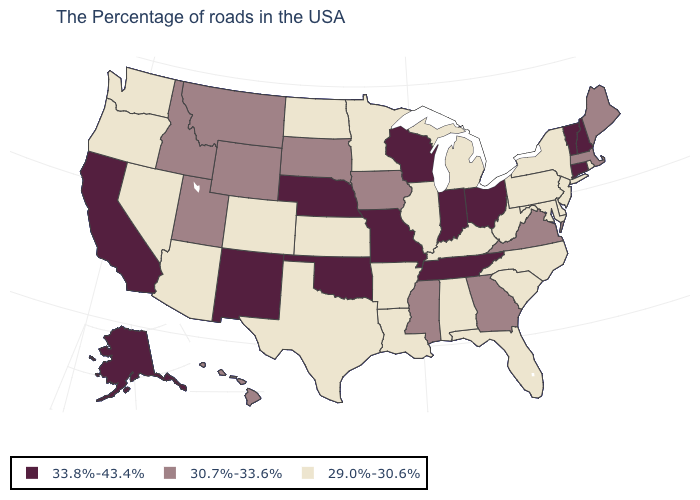Name the states that have a value in the range 29.0%-30.6%?
Keep it brief. Rhode Island, New York, New Jersey, Delaware, Maryland, Pennsylvania, North Carolina, South Carolina, West Virginia, Florida, Michigan, Kentucky, Alabama, Illinois, Louisiana, Arkansas, Minnesota, Kansas, Texas, North Dakota, Colorado, Arizona, Nevada, Washington, Oregon. What is the value of Massachusetts?
Short answer required. 30.7%-33.6%. How many symbols are there in the legend?
Short answer required. 3. What is the value of Georgia?
Give a very brief answer. 30.7%-33.6%. Among the states that border North Dakota , which have the highest value?
Concise answer only. South Dakota, Montana. What is the value of South Carolina?
Concise answer only. 29.0%-30.6%. Name the states that have a value in the range 30.7%-33.6%?
Quick response, please. Maine, Massachusetts, Virginia, Georgia, Mississippi, Iowa, South Dakota, Wyoming, Utah, Montana, Idaho, Hawaii. What is the highest value in the MidWest ?
Keep it brief. 33.8%-43.4%. What is the lowest value in the South?
Concise answer only. 29.0%-30.6%. Name the states that have a value in the range 29.0%-30.6%?
Short answer required. Rhode Island, New York, New Jersey, Delaware, Maryland, Pennsylvania, North Carolina, South Carolina, West Virginia, Florida, Michigan, Kentucky, Alabama, Illinois, Louisiana, Arkansas, Minnesota, Kansas, Texas, North Dakota, Colorado, Arizona, Nevada, Washington, Oregon. Does New Mexico have the highest value in the USA?
Give a very brief answer. Yes. Name the states that have a value in the range 30.7%-33.6%?
Short answer required. Maine, Massachusetts, Virginia, Georgia, Mississippi, Iowa, South Dakota, Wyoming, Utah, Montana, Idaho, Hawaii. What is the value of Delaware?
Keep it brief. 29.0%-30.6%. What is the value of Ohio?
Short answer required. 33.8%-43.4%. 